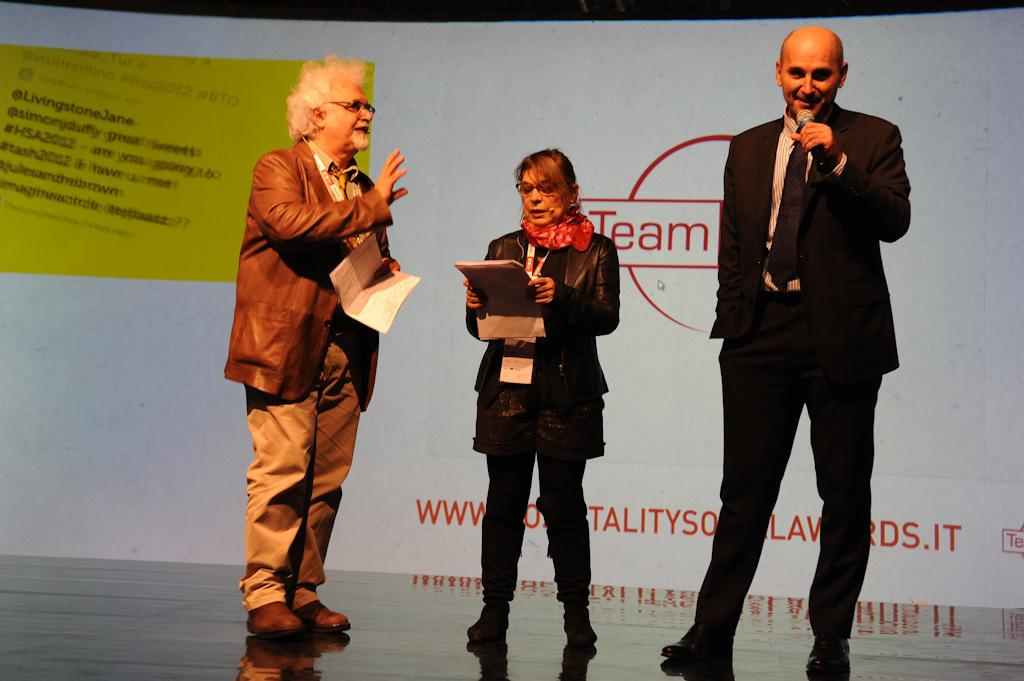How many people are in the image? There are three persons standing in the image. What are the people holding in their hands? Each person is holding a microphone and papers. What can be seen in the background of the image? There is a banner visible in the background of the image. What type of liquid is being poured from the hammer in the image? There is no liquid or hammer present in the image. What is the mass of the object being held by the person on the left in the image? There is no object being held by the person on the left in the image, as they are holding a microphone and papers. 